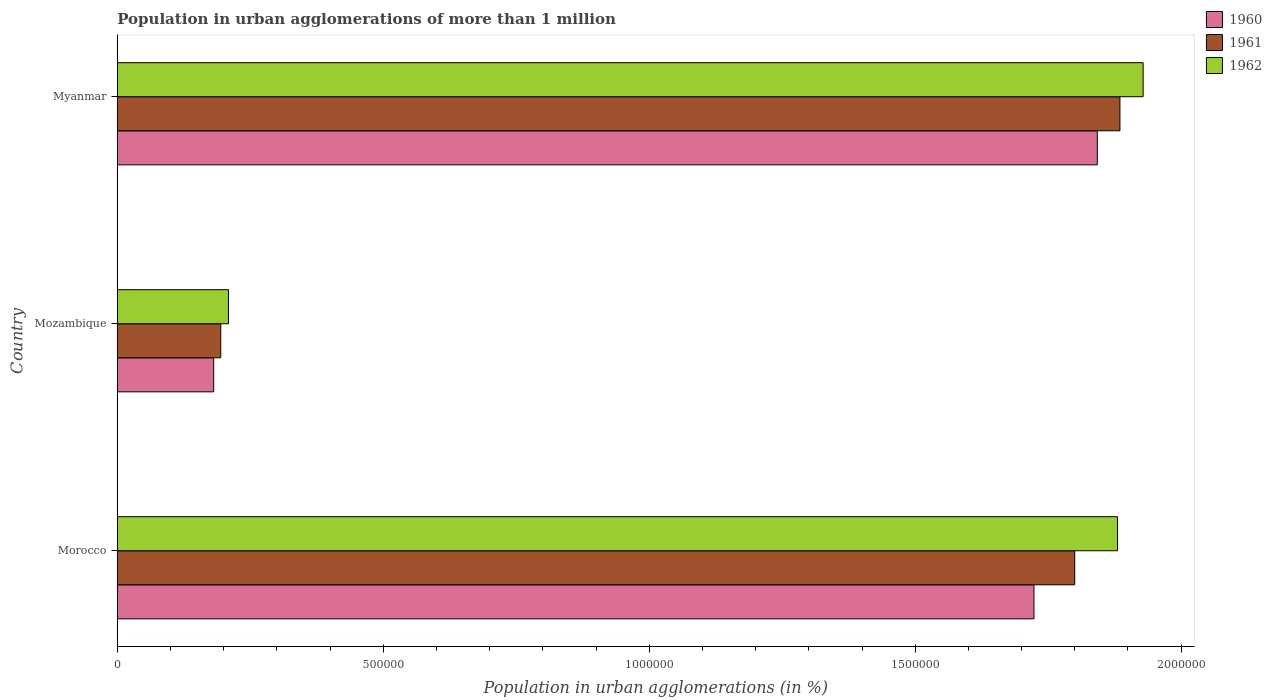How many groups of bars are there?
Your answer should be very brief. 3. Are the number of bars on each tick of the Y-axis equal?
Your answer should be very brief. Yes. How many bars are there on the 1st tick from the top?
Offer a terse response. 3. How many bars are there on the 1st tick from the bottom?
Give a very brief answer. 3. What is the label of the 3rd group of bars from the top?
Make the answer very short. Morocco. In how many cases, is the number of bars for a given country not equal to the number of legend labels?
Your answer should be compact. 0. What is the population in urban agglomerations in 1961 in Myanmar?
Your answer should be compact. 1.88e+06. Across all countries, what is the maximum population in urban agglomerations in 1962?
Provide a succinct answer. 1.93e+06. Across all countries, what is the minimum population in urban agglomerations in 1960?
Keep it short and to the point. 1.81e+05. In which country was the population in urban agglomerations in 1961 maximum?
Keep it short and to the point. Myanmar. In which country was the population in urban agglomerations in 1960 minimum?
Your answer should be very brief. Mozambique. What is the total population in urban agglomerations in 1960 in the graph?
Make the answer very short. 3.75e+06. What is the difference between the population in urban agglomerations in 1961 in Morocco and that in Mozambique?
Your answer should be very brief. 1.61e+06. What is the difference between the population in urban agglomerations in 1962 in Myanmar and the population in urban agglomerations in 1960 in Mozambique?
Provide a succinct answer. 1.75e+06. What is the average population in urban agglomerations in 1960 per country?
Make the answer very short. 1.25e+06. What is the difference between the population in urban agglomerations in 1960 and population in urban agglomerations in 1962 in Myanmar?
Your answer should be very brief. -8.61e+04. In how many countries, is the population in urban agglomerations in 1961 greater than 1800000 %?
Keep it short and to the point. 1. What is the ratio of the population in urban agglomerations in 1962 in Morocco to that in Mozambique?
Offer a very short reply. 9. Is the population in urban agglomerations in 1961 in Mozambique less than that in Myanmar?
Make the answer very short. Yes. Is the difference between the population in urban agglomerations in 1960 in Morocco and Myanmar greater than the difference between the population in urban agglomerations in 1962 in Morocco and Myanmar?
Your answer should be very brief. No. What is the difference between the highest and the second highest population in urban agglomerations in 1962?
Your answer should be compact. 4.81e+04. What is the difference between the highest and the lowest population in urban agglomerations in 1960?
Make the answer very short. 1.66e+06. In how many countries, is the population in urban agglomerations in 1960 greater than the average population in urban agglomerations in 1960 taken over all countries?
Keep it short and to the point. 2. Is the sum of the population in urban agglomerations in 1960 in Morocco and Mozambique greater than the maximum population in urban agglomerations in 1962 across all countries?
Ensure brevity in your answer.  No. What does the 1st bar from the bottom in Mozambique represents?
Offer a very short reply. 1960. How many bars are there?
Make the answer very short. 9. Are all the bars in the graph horizontal?
Keep it short and to the point. Yes. How many countries are there in the graph?
Your answer should be compact. 3. Does the graph contain any zero values?
Make the answer very short. No. Does the graph contain grids?
Give a very brief answer. No. What is the title of the graph?
Keep it short and to the point. Population in urban agglomerations of more than 1 million. What is the label or title of the X-axis?
Your response must be concise. Population in urban agglomerations (in %). What is the Population in urban agglomerations (in %) of 1960 in Morocco?
Your answer should be compact. 1.72e+06. What is the Population in urban agglomerations (in %) in 1961 in Morocco?
Keep it short and to the point. 1.80e+06. What is the Population in urban agglomerations (in %) of 1962 in Morocco?
Provide a succinct answer. 1.88e+06. What is the Population in urban agglomerations (in %) of 1960 in Mozambique?
Your answer should be very brief. 1.81e+05. What is the Population in urban agglomerations (in %) in 1961 in Mozambique?
Offer a very short reply. 1.95e+05. What is the Population in urban agglomerations (in %) in 1962 in Mozambique?
Make the answer very short. 2.09e+05. What is the Population in urban agglomerations (in %) of 1960 in Myanmar?
Your response must be concise. 1.84e+06. What is the Population in urban agglomerations (in %) of 1961 in Myanmar?
Keep it short and to the point. 1.88e+06. What is the Population in urban agglomerations (in %) in 1962 in Myanmar?
Provide a succinct answer. 1.93e+06. Across all countries, what is the maximum Population in urban agglomerations (in %) of 1960?
Give a very brief answer. 1.84e+06. Across all countries, what is the maximum Population in urban agglomerations (in %) in 1961?
Offer a very short reply. 1.88e+06. Across all countries, what is the maximum Population in urban agglomerations (in %) of 1962?
Your answer should be compact. 1.93e+06. Across all countries, what is the minimum Population in urban agglomerations (in %) of 1960?
Ensure brevity in your answer.  1.81e+05. Across all countries, what is the minimum Population in urban agglomerations (in %) of 1961?
Your answer should be very brief. 1.95e+05. Across all countries, what is the minimum Population in urban agglomerations (in %) in 1962?
Ensure brevity in your answer.  2.09e+05. What is the total Population in urban agglomerations (in %) of 1960 in the graph?
Offer a terse response. 3.75e+06. What is the total Population in urban agglomerations (in %) of 1961 in the graph?
Offer a very short reply. 3.88e+06. What is the total Population in urban agglomerations (in %) of 1962 in the graph?
Provide a short and direct response. 4.02e+06. What is the difference between the Population in urban agglomerations (in %) of 1960 in Morocco and that in Mozambique?
Provide a short and direct response. 1.54e+06. What is the difference between the Population in urban agglomerations (in %) of 1961 in Morocco and that in Mozambique?
Offer a very short reply. 1.61e+06. What is the difference between the Population in urban agglomerations (in %) in 1962 in Morocco and that in Mozambique?
Give a very brief answer. 1.67e+06. What is the difference between the Population in urban agglomerations (in %) in 1960 in Morocco and that in Myanmar?
Keep it short and to the point. -1.19e+05. What is the difference between the Population in urban agglomerations (in %) of 1961 in Morocco and that in Myanmar?
Your answer should be compact. -8.50e+04. What is the difference between the Population in urban agglomerations (in %) of 1962 in Morocco and that in Myanmar?
Offer a terse response. -4.81e+04. What is the difference between the Population in urban agglomerations (in %) of 1960 in Mozambique and that in Myanmar?
Your answer should be very brief. -1.66e+06. What is the difference between the Population in urban agglomerations (in %) of 1961 in Mozambique and that in Myanmar?
Offer a terse response. -1.69e+06. What is the difference between the Population in urban agglomerations (in %) of 1962 in Mozambique and that in Myanmar?
Make the answer very short. -1.72e+06. What is the difference between the Population in urban agglomerations (in %) of 1960 in Morocco and the Population in urban agglomerations (in %) of 1961 in Mozambique?
Your response must be concise. 1.53e+06. What is the difference between the Population in urban agglomerations (in %) of 1960 in Morocco and the Population in urban agglomerations (in %) of 1962 in Mozambique?
Make the answer very short. 1.51e+06. What is the difference between the Population in urban agglomerations (in %) of 1961 in Morocco and the Population in urban agglomerations (in %) of 1962 in Mozambique?
Ensure brevity in your answer.  1.59e+06. What is the difference between the Population in urban agglomerations (in %) of 1960 in Morocco and the Population in urban agglomerations (in %) of 1961 in Myanmar?
Ensure brevity in your answer.  -1.62e+05. What is the difference between the Population in urban agglomerations (in %) of 1960 in Morocco and the Population in urban agglomerations (in %) of 1962 in Myanmar?
Keep it short and to the point. -2.05e+05. What is the difference between the Population in urban agglomerations (in %) in 1961 in Morocco and the Population in urban agglomerations (in %) in 1962 in Myanmar?
Ensure brevity in your answer.  -1.29e+05. What is the difference between the Population in urban agglomerations (in %) in 1960 in Mozambique and the Population in urban agglomerations (in %) in 1961 in Myanmar?
Offer a very short reply. -1.70e+06. What is the difference between the Population in urban agglomerations (in %) in 1960 in Mozambique and the Population in urban agglomerations (in %) in 1962 in Myanmar?
Offer a terse response. -1.75e+06. What is the difference between the Population in urban agglomerations (in %) in 1961 in Mozambique and the Population in urban agglomerations (in %) in 1962 in Myanmar?
Provide a short and direct response. -1.73e+06. What is the average Population in urban agglomerations (in %) in 1960 per country?
Your answer should be very brief. 1.25e+06. What is the average Population in urban agglomerations (in %) of 1961 per country?
Ensure brevity in your answer.  1.29e+06. What is the average Population in urban agglomerations (in %) of 1962 per country?
Keep it short and to the point. 1.34e+06. What is the difference between the Population in urban agglomerations (in %) in 1960 and Population in urban agglomerations (in %) in 1961 in Morocco?
Your answer should be very brief. -7.66e+04. What is the difference between the Population in urban agglomerations (in %) in 1960 and Population in urban agglomerations (in %) in 1962 in Morocco?
Keep it short and to the point. -1.57e+05. What is the difference between the Population in urban agglomerations (in %) in 1961 and Population in urban agglomerations (in %) in 1962 in Morocco?
Ensure brevity in your answer.  -8.05e+04. What is the difference between the Population in urban agglomerations (in %) in 1960 and Population in urban agglomerations (in %) in 1961 in Mozambique?
Offer a very short reply. -1.33e+04. What is the difference between the Population in urban agglomerations (in %) of 1960 and Population in urban agglomerations (in %) of 1962 in Mozambique?
Offer a terse response. -2.78e+04. What is the difference between the Population in urban agglomerations (in %) in 1961 and Population in urban agglomerations (in %) in 1962 in Mozambique?
Keep it short and to the point. -1.45e+04. What is the difference between the Population in urban agglomerations (in %) in 1960 and Population in urban agglomerations (in %) in 1961 in Myanmar?
Ensure brevity in your answer.  -4.25e+04. What is the difference between the Population in urban agglomerations (in %) in 1960 and Population in urban agglomerations (in %) in 1962 in Myanmar?
Give a very brief answer. -8.61e+04. What is the difference between the Population in urban agglomerations (in %) of 1961 and Population in urban agglomerations (in %) of 1962 in Myanmar?
Your answer should be very brief. -4.36e+04. What is the ratio of the Population in urban agglomerations (in %) in 1960 in Morocco to that in Mozambique?
Your answer should be compact. 9.51. What is the ratio of the Population in urban agglomerations (in %) of 1961 in Morocco to that in Mozambique?
Make the answer very short. 9.25. What is the ratio of the Population in urban agglomerations (in %) in 1962 in Morocco to that in Mozambique?
Offer a terse response. 9. What is the ratio of the Population in urban agglomerations (in %) of 1960 in Morocco to that in Myanmar?
Your answer should be compact. 0.94. What is the ratio of the Population in urban agglomerations (in %) in 1961 in Morocco to that in Myanmar?
Offer a terse response. 0.95. What is the ratio of the Population in urban agglomerations (in %) in 1962 in Morocco to that in Myanmar?
Keep it short and to the point. 0.98. What is the ratio of the Population in urban agglomerations (in %) in 1960 in Mozambique to that in Myanmar?
Your answer should be compact. 0.1. What is the ratio of the Population in urban agglomerations (in %) in 1961 in Mozambique to that in Myanmar?
Provide a short and direct response. 0.1. What is the ratio of the Population in urban agglomerations (in %) of 1962 in Mozambique to that in Myanmar?
Offer a terse response. 0.11. What is the difference between the highest and the second highest Population in urban agglomerations (in %) of 1960?
Your answer should be compact. 1.19e+05. What is the difference between the highest and the second highest Population in urban agglomerations (in %) of 1961?
Ensure brevity in your answer.  8.50e+04. What is the difference between the highest and the second highest Population in urban agglomerations (in %) of 1962?
Offer a terse response. 4.81e+04. What is the difference between the highest and the lowest Population in urban agglomerations (in %) of 1960?
Your answer should be very brief. 1.66e+06. What is the difference between the highest and the lowest Population in urban agglomerations (in %) of 1961?
Ensure brevity in your answer.  1.69e+06. What is the difference between the highest and the lowest Population in urban agglomerations (in %) of 1962?
Provide a succinct answer. 1.72e+06. 